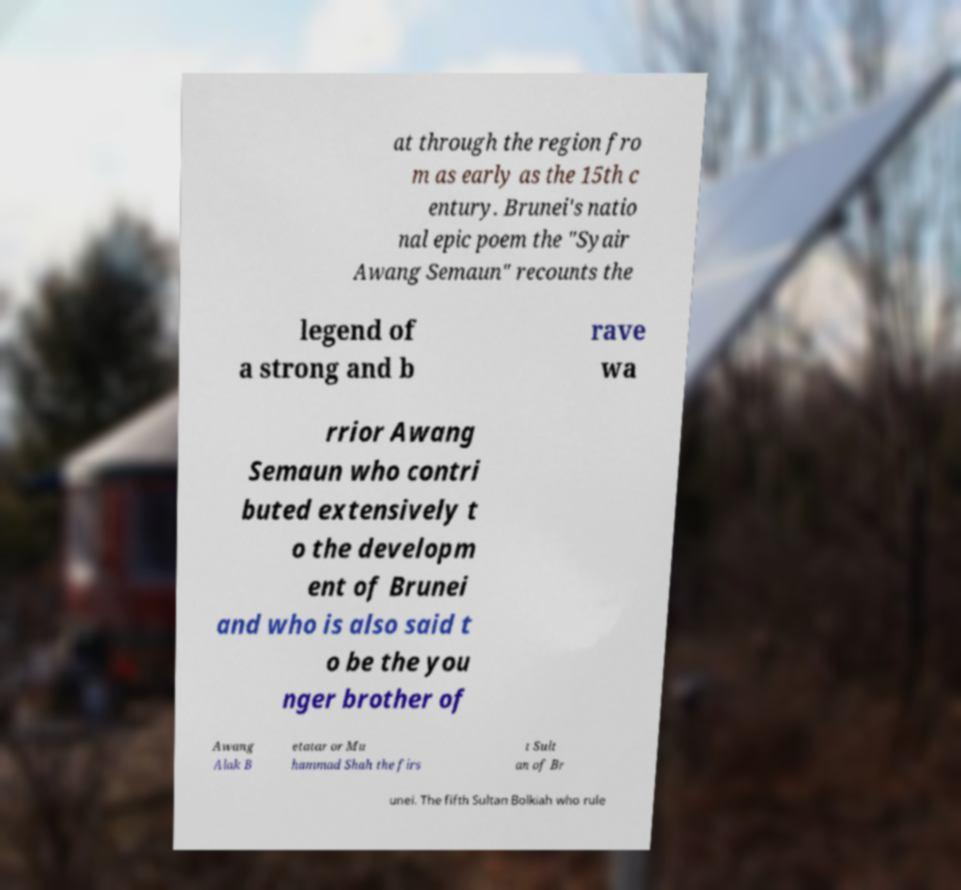There's text embedded in this image that I need extracted. Can you transcribe it verbatim? at through the region fro m as early as the 15th c entury. Brunei's natio nal epic poem the "Syair Awang Semaun" recounts the legend of a strong and b rave wa rrior Awang Semaun who contri buted extensively t o the developm ent of Brunei and who is also said t o be the you nger brother of Awang Alak B etatar or Mu hammad Shah the firs t Sult an of Br unei. The fifth Sultan Bolkiah who rule 